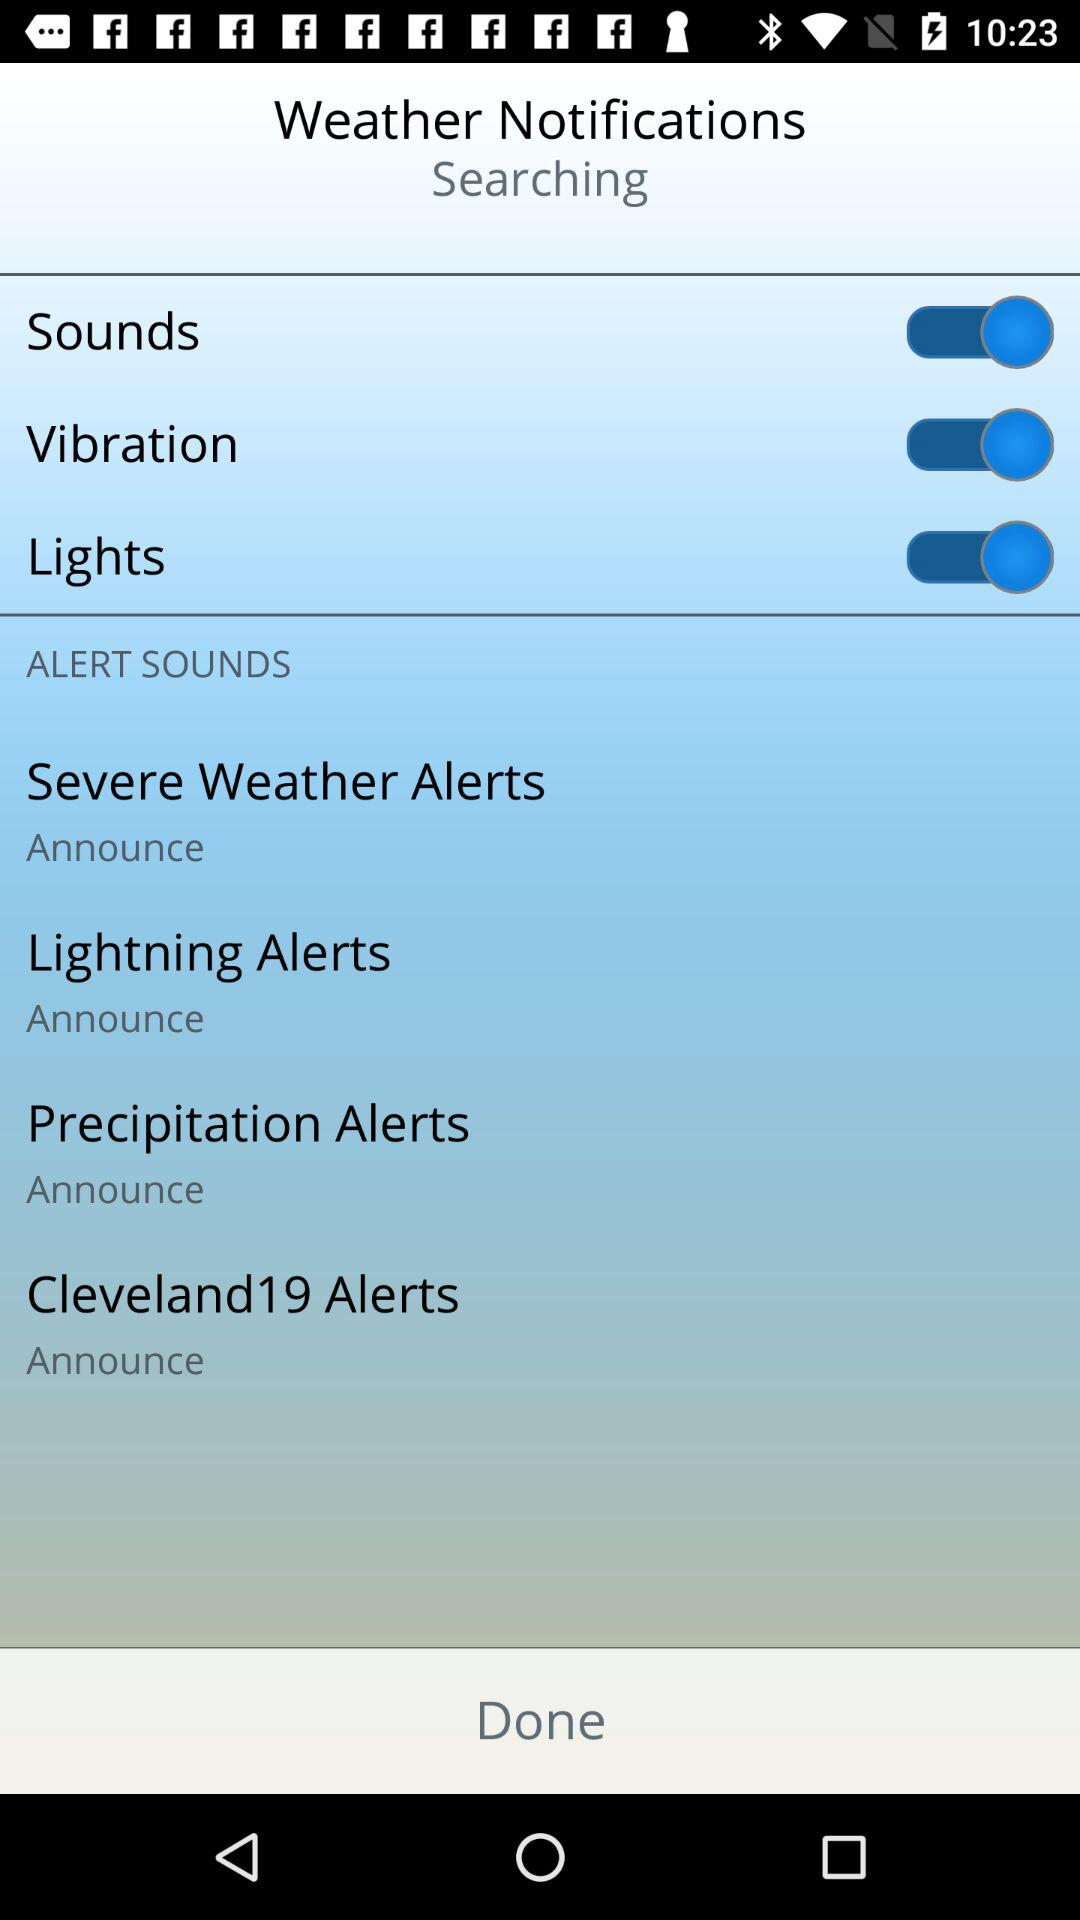What is the status of the "Sounds" setting? The status is "on". 